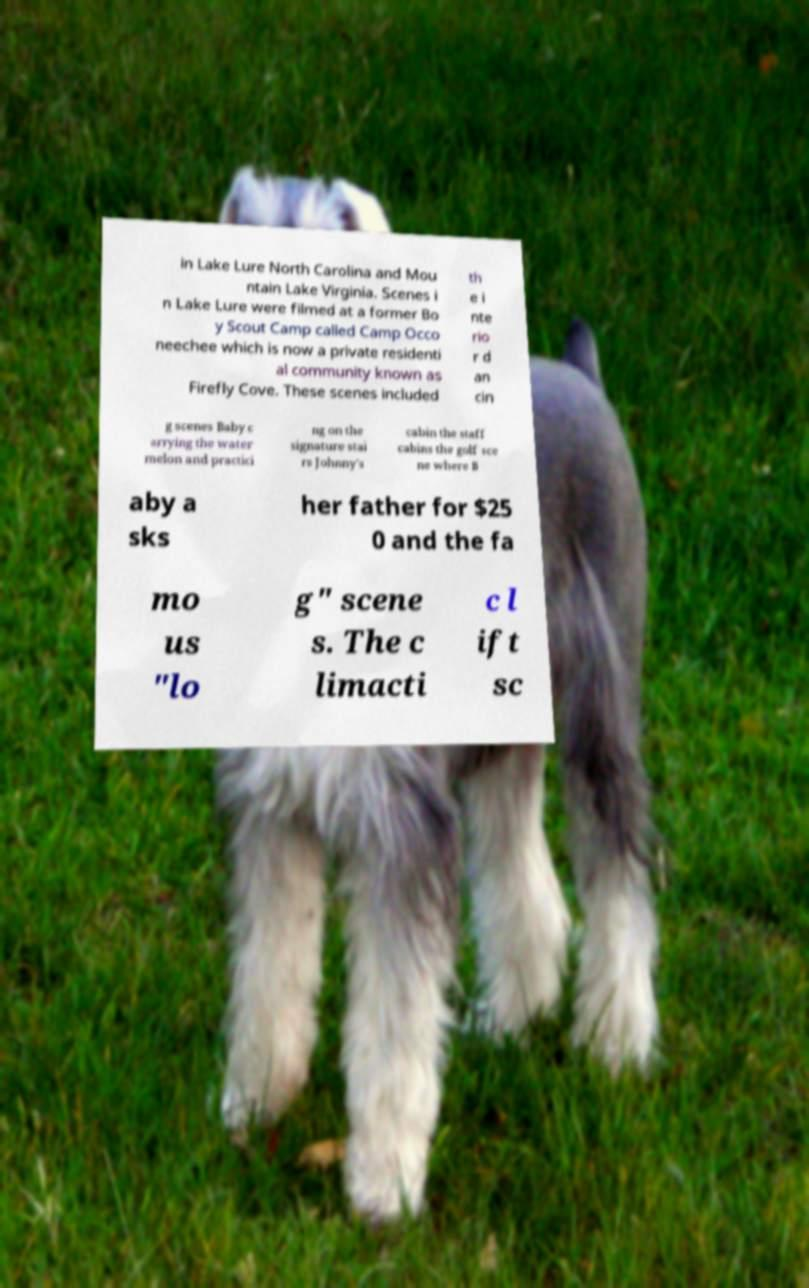Please identify and transcribe the text found in this image. in Lake Lure North Carolina and Mou ntain Lake Virginia. Scenes i n Lake Lure were filmed at a former Bo y Scout Camp called Camp Occo neechee which is now a private residenti al community known as Firefly Cove. These scenes included th e i nte rio r d an cin g scenes Baby c arrying the water melon and practici ng on the signature stai rs Johnny's cabin the staff cabins the golf sce ne where B aby a sks her father for $25 0 and the fa mo us "lo g" scene s. The c limacti c l ift sc 